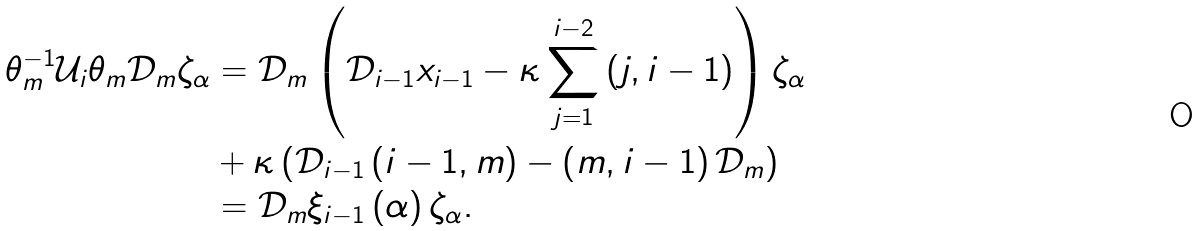<formula> <loc_0><loc_0><loc_500><loc_500>\theta _ { m } ^ { - 1 } \mathcal { U } _ { i } \theta _ { m } \mathcal { D } _ { m } \zeta _ { \alpha } & = \mathcal { D } _ { m } \left ( \mathcal { D } _ { i - 1 } x _ { i - 1 } - \kappa \sum _ { j = 1 } ^ { i - 2 } \left ( j , i - 1 \right ) \right ) \zeta _ { \alpha } \\ & + \kappa \left ( \mathcal { D } _ { i - 1 } \left ( i - 1 , m \right ) - \left ( m , i - 1 \right ) \mathcal { D } _ { m } \right ) \\ & = \mathcal { D } _ { m } \xi _ { i - 1 } \left ( \alpha \right ) \zeta _ { \alpha } .</formula> 